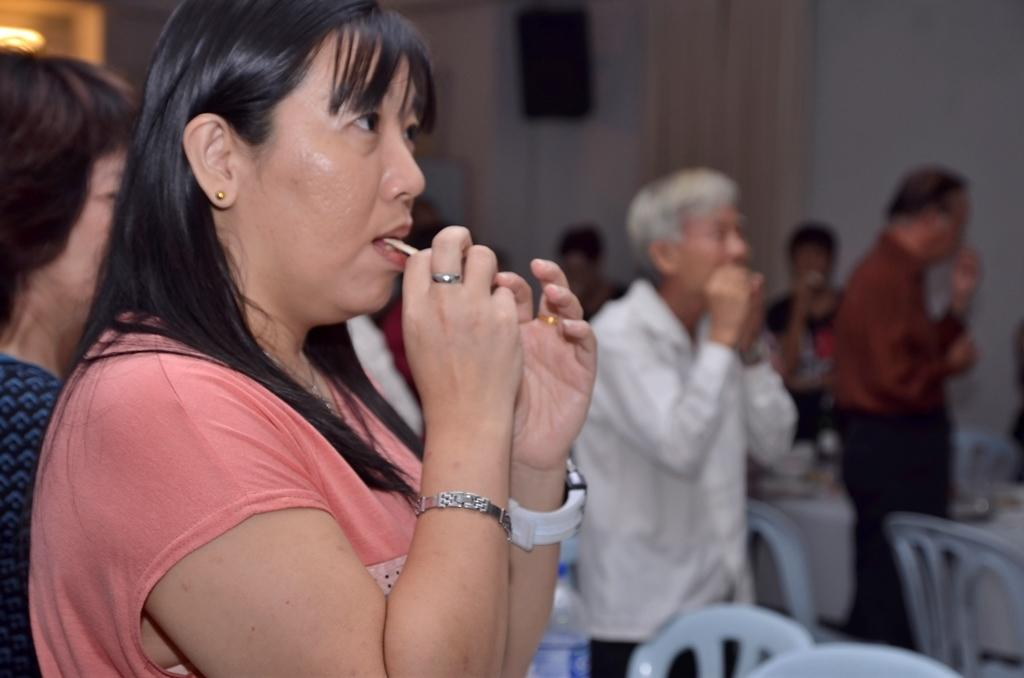How many people are in the image? There are people in the image, but the exact number is not specified. What is the lady doing in the image? A lady is eating a food item in the image. What type of furniture is present in the image? There are chairs and a table in the image. Can you describe the lighting in the image? There is a light in the image. What is the background of the image like? The background of the image is blurred. What type of amusement is the queen enjoying in the image? There is no queen or amusement present in the image. How many folds are visible in the lady's dress in the image? The facts provided do not mention any details about the lady's dress, so we cannot determine the number of folds. 